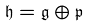Convert formula to latex. <formula><loc_0><loc_0><loc_500><loc_500>\mathfrak { h } = \mathfrak { g } \oplus \mathfrak { p }</formula> 